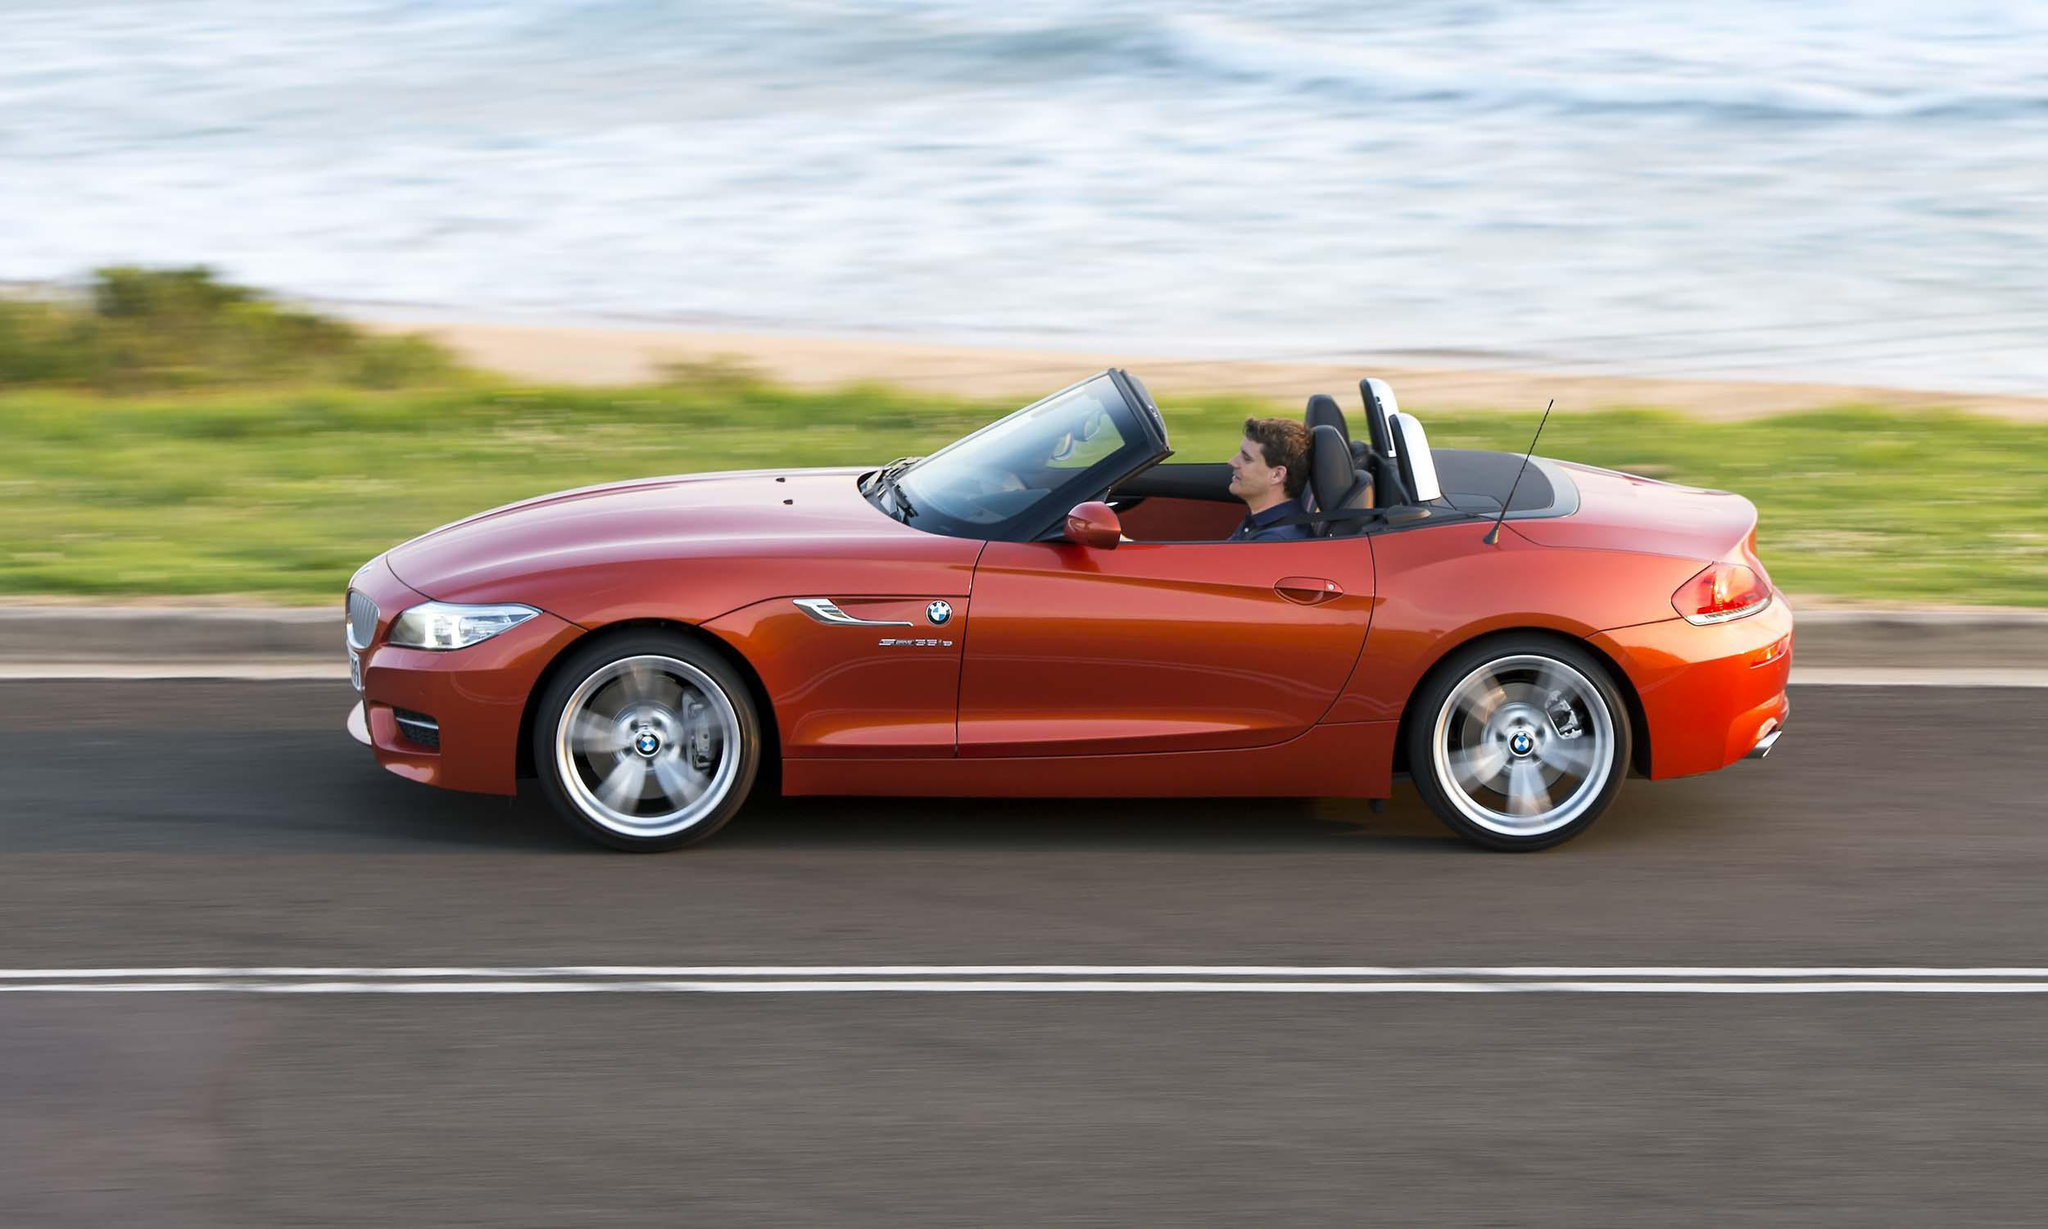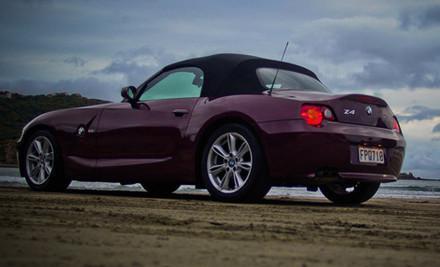The first image is the image on the left, the second image is the image on the right. For the images shown, is this caption "One image has an orange BMW facing the right." true? Answer yes or no. No. 